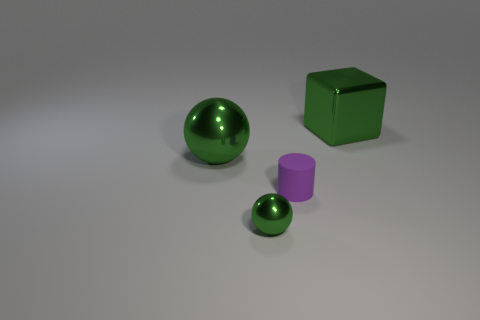The shiny object that is to the right of the large green ball and to the left of the large green metallic block is what color?
Provide a short and direct response. Green. How many other objects are there of the same shape as the tiny purple thing?
Your answer should be compact. 0. Are there fewer small rubber cylinders behind the large sphere than shiny cubes on the left side of the tiny green metal sphere?
Keep it short and to the point. No. Is the tiny purple cylinder made of the same material as the object that is behind the big green sphere?
Ensure brevity in your answer.  No. Is there any other thing that has the same material as the tiny green thing?
Your answer should be compact. Yes. Are there more rubber things than objects?
Offer a very short reply. No. There is a metal thing on the right side of the ball that is in front of the large green shiny object that is in front of the green metallic cube; what shape is it?
Your answer should be very brief. Cube. Is the green object in front of the small purple rubber thing made of the same material as the green object to the right of the tiny green thing?
Offer a very short reply. Yes. What is the shape of the large thing that is made of the same material as the large sphere?
Provide a short and direct response. Cube. Is there anything else that is the same color as the cylinder?
Keep it short and to the point. No. 